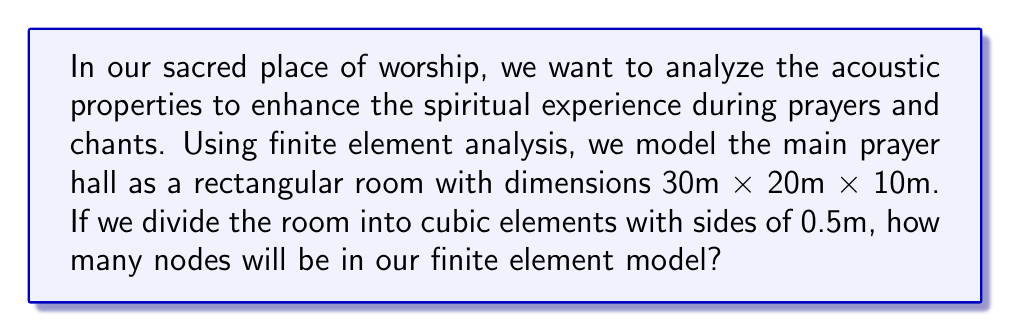Can you solve this math problem? To solve this problem, we'll follow these steps:

1) First, let's calculate the number of elements along each dimension:
   Length: $30 \text{ m} \div 0.5 \text{ m} = 60$ elements
   Width: $20 \text{ m} \div 0.5 \text{ m} = 40$ elements
   Height: $10 \text{ m} \div 0.5 \text{ m} = 20$ elements

2) Now, we need to calculate the number of nodes. In a finite element mesh, nodes are shared between adjacent elements. So, we need to add 1 to each dimension to get the number of nodes:
   Length: $60 + 1 = 61$ nodes
   Width: $40 + 1 = 41$ nodes
   Height: $20 + 1 = 21$ nodes

3) The total number of nodes is the product of these three numbers:

   $$\text{Total nodes} = 61 \times 41 \times 21$$

4) Let's compute this:
   $$\text{Total nodes} = 61 \times 41 \times 21 = 52,521$$

Therefore, our finite element model will have 52,521 nodes.
Answer: 52,521 nodes 